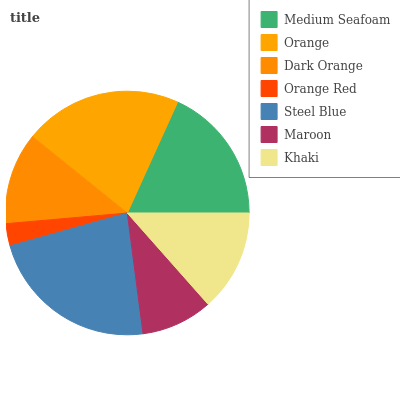Is Orange Red the minimum?
Answer yes or no. Yes. Is Steel Blue the maximum?
Answer yes or no. Yes. Is Orange the minimum?
Answer yes or no. No. Is Orange the maximum?
Answer yes or no. No. Is Orange greater than Medium Seafoam?
Answer yes or no. Yes. Is Medium Seafoam less than Orange?
Answer yes or no. Yes. Is Medium Seafoam greater than Orange?
Answer yes or no. No. Is Orange less than Medium Seafoam?
Answer yes or no. No. Is Khaki the high median?
Answer yes or no. Yes. Is Khaki the low median?
Answer yes or no. Yes. Is Medium Seafoam the high median?
Answer yes or no. No. Is Orange Red the low median?
Answer yes or no. No. 